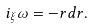<formula> <loc_0><loc_0><loc_500><loc_500>i _ { \xi } \omega = - r d r .</formula> 